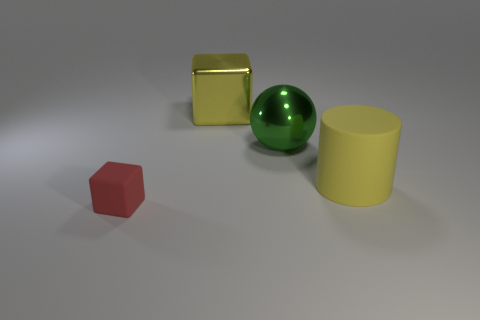What number of other objects are there of the same color as the large cylinder?
Make the answer very short. 1. Does the shiny sphere have the same color as the matte cylinder?
Your answer should be very brief. No. How many other tiny objects have the same shape as the small red matte thing?
Provide a succinct answer. 0. There is a yellow cube that is the same material as the green object; what size is it?
Offer a terse response. Large. There is a thing that is both on the left side of the yellow cylinder and in front of the ball; what is its color?
Keep it short and to the point. Red. How many green metal spheres are the same size as the matte cylinder?
Provide a succinct answer. 1. The rubber thing that is the same color as the big metal block is what size?
Ensure brevity in your answer.  Large. There is a object that is both left of the cylinder and in front of the green object; how big is it?
Your response must be concise. Small. What number of things are left of the metallic thing that is on the right side of the yellow object on the left side of the large matte thing?
Give a very brief answer. 2. Is there a tiny rubber block that has the same color as the small rubber thing?
Your answer should be compact. No. 